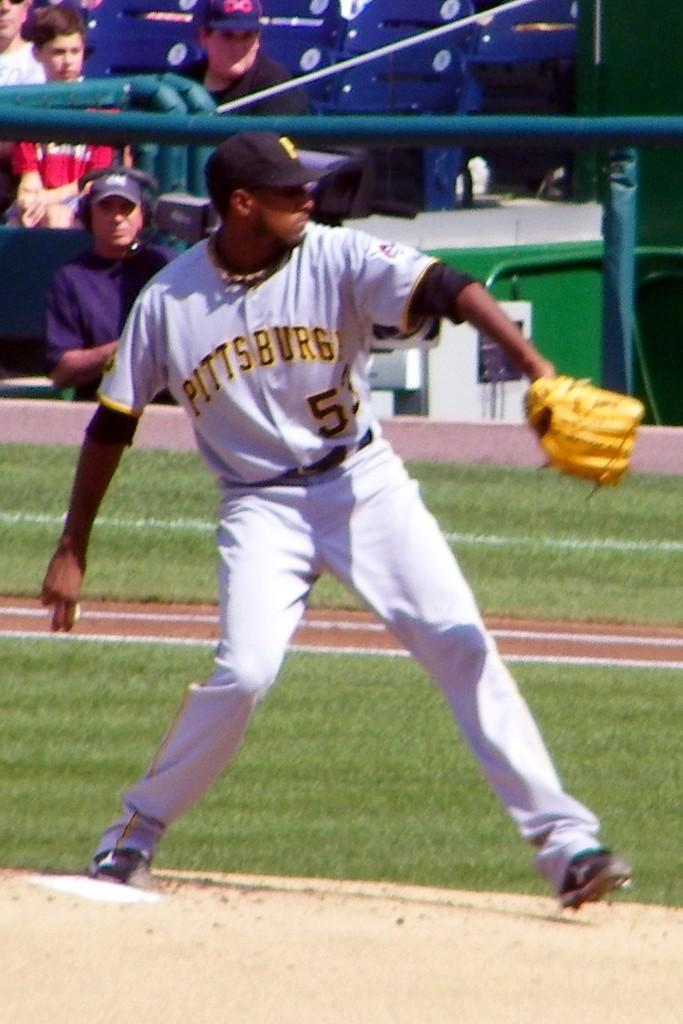Provide a one-sentence caption for the provided image. A Pittsburgh Baseball Player prepares to throw the ball. 